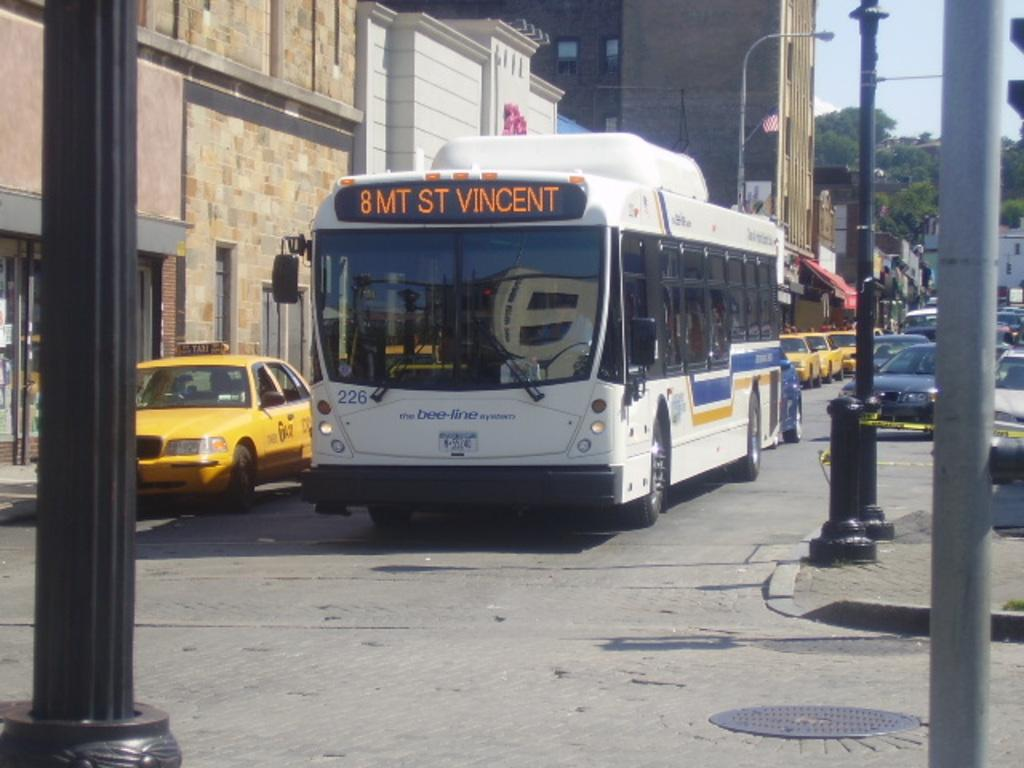<image>
Relay a brief, clear account of the picture shown. A line of taxi cabs are parked on a street with a bus in the road having 8 MT ST VINCENT at the top front. 